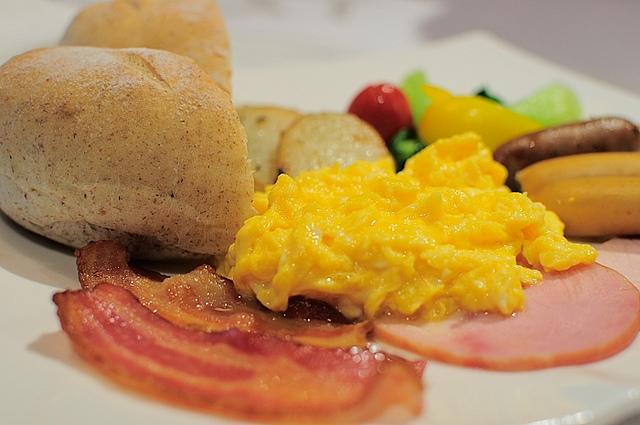Does this food look tasty?
Be succinct. No. Is the pastry on a plate?
Concise answer only. No. Is this breakfast?
Keep it brief. Yes. Do you see bacon?
Answer briefly. Yes. How many kinds of meat are there?
Short answer required. 3. What did they make out of the bread?
Be succinct. Rolls. 